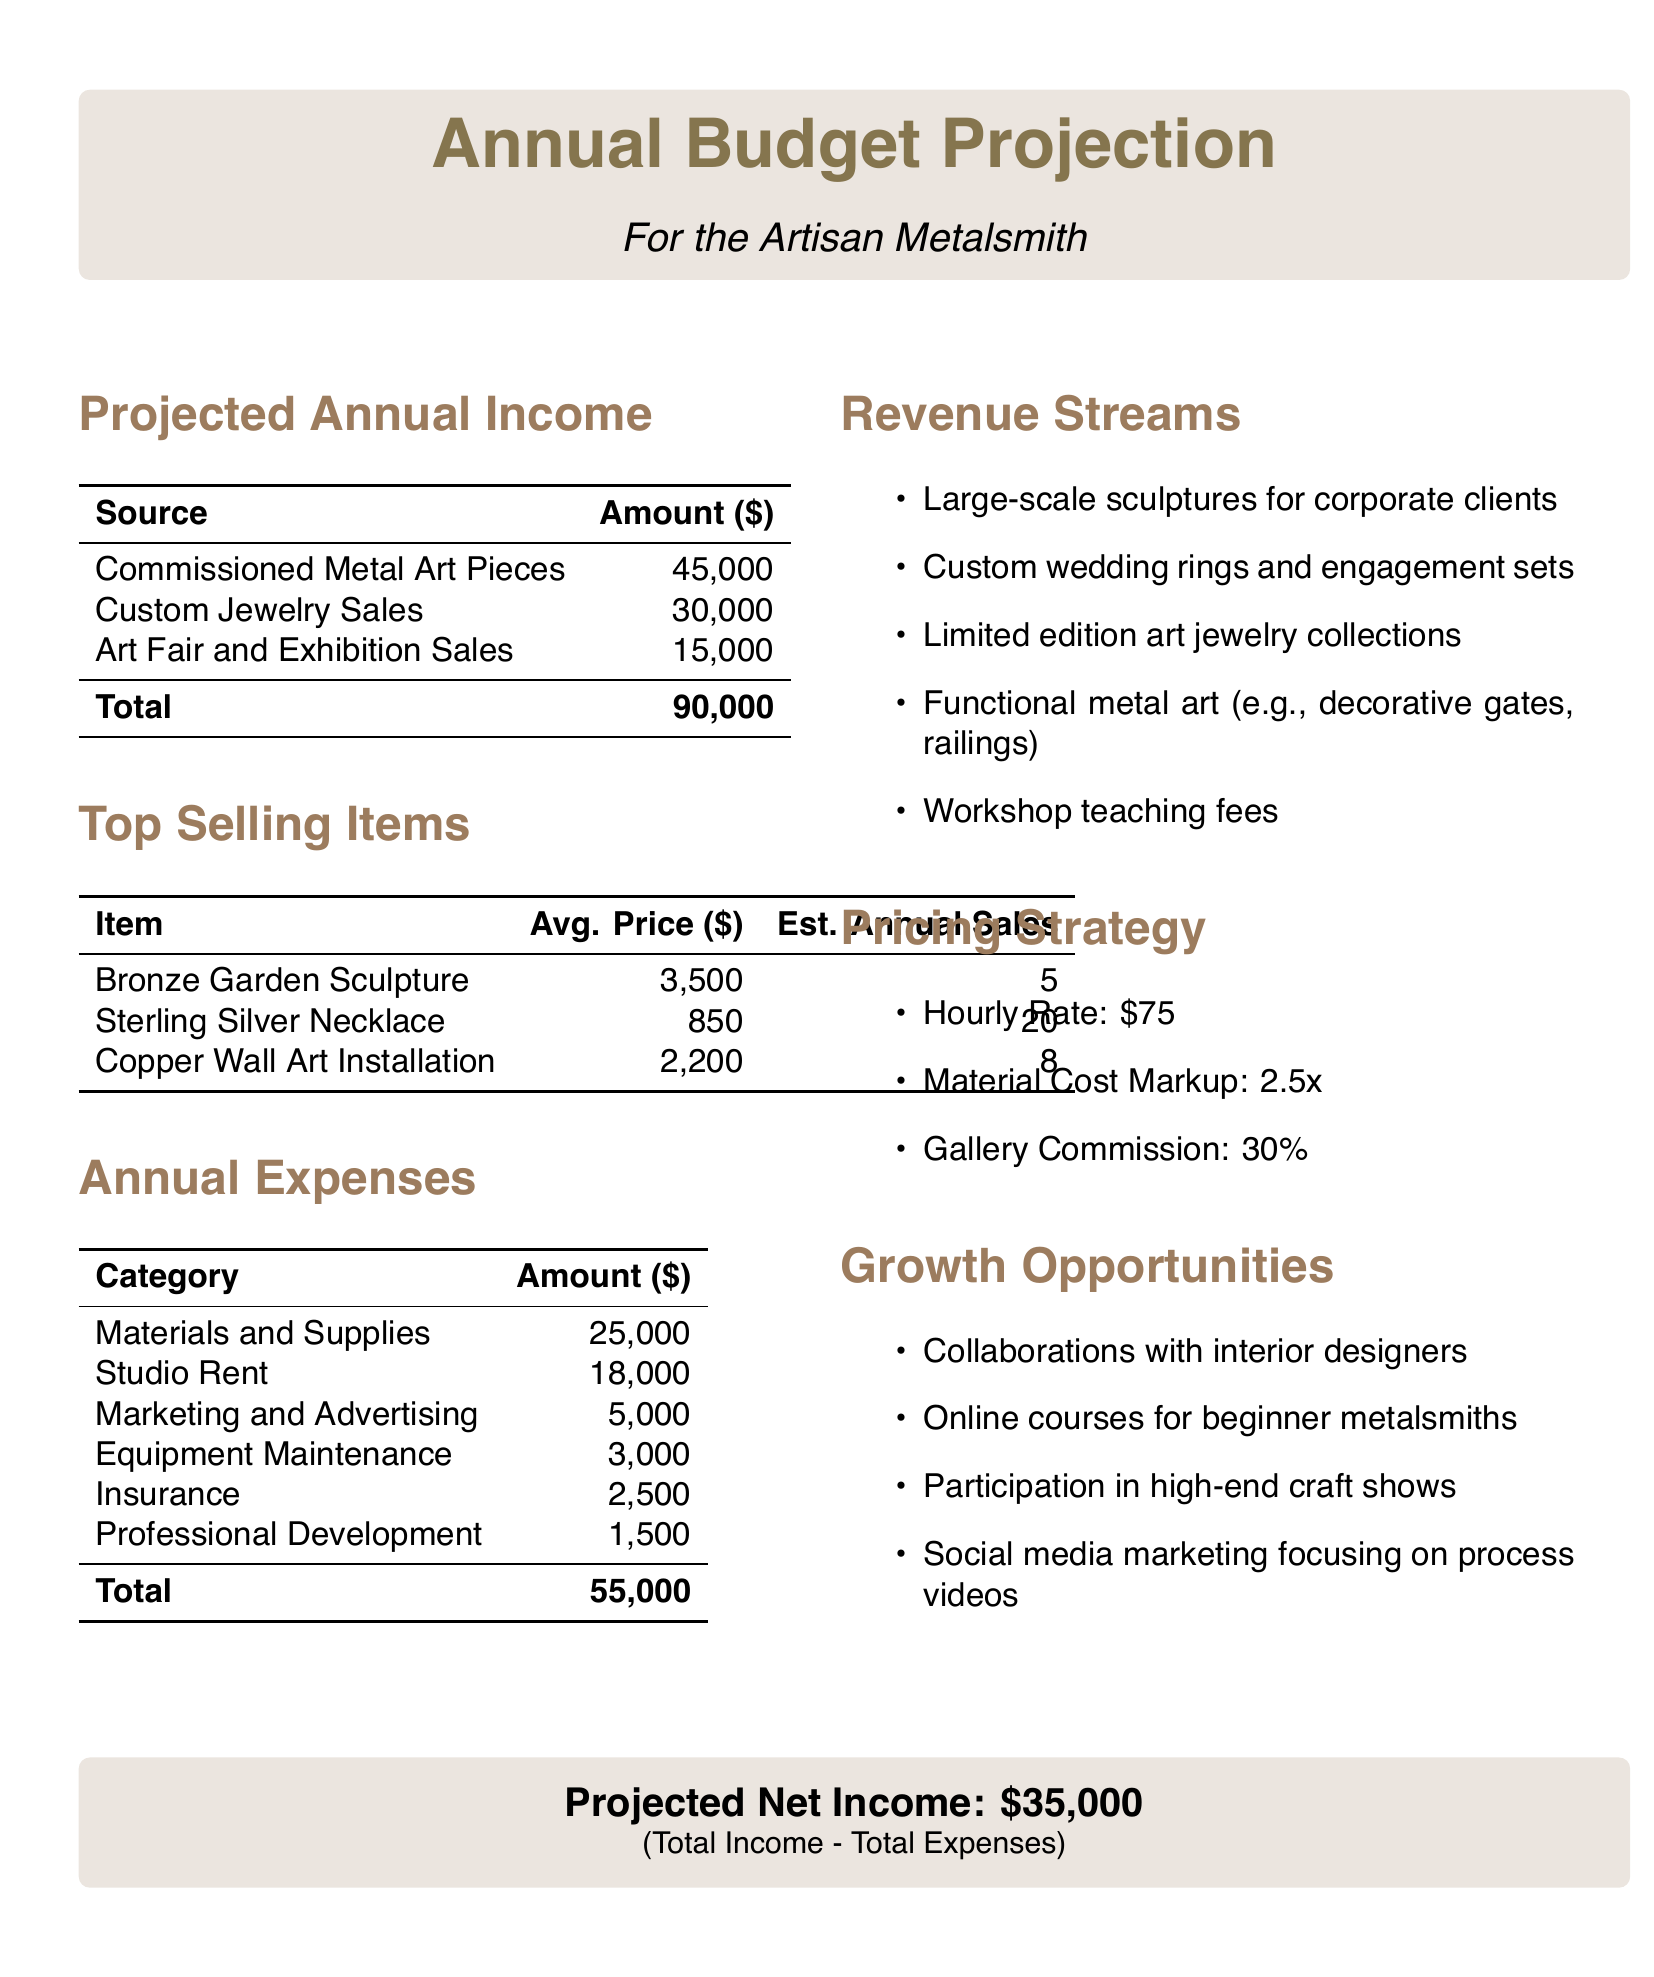What is the total projected income? The total projected income is the sum of all income sources listed in the document, which is $45,000 + $30,000 + $15,000.
Answer: $90,000 What is the average price of a Sterling Silver Necklace? The average price of a Sterling Silver Necklace is given in the top-selling items table in the document.
Answer: $850 What are the total annual expenses? The total annual expenses are calculated by summing all listed expenses in the document: $25,000 + $18,000 + $5,000 + $3,000 + $2,500 + $1,500.
Answer: $55,000 What is the estimated annual sales for the Bronze Garden Sculpture? The estimated annual sales for the Bronze Garden Sculpture is stated in the document under the top-selling items section.
Answer: 5 What is the projected net income? The projected net income is derived from the difference between total income and total expenses, as summarized in the document.
Answer: $35,000 What is the hourly rate used in the pricing strategy? The hourly rate is specified under the pricing strategy section of the document.
Answer: $75 What type of items are included in the revenue streams? This query requires identifying a specific category from the document that lists different sources of income.
Answer: Large-scale sculptures for corporate clients What is the material cost markup in the pricing strategy? This information is included in the pricing strategy section of the document as part of the pricing approach.
Answer: 2.5x What are the annual expenses for studio rent? The amount for studio rent is listed under the annual expenses section.
Answer: $18,000 